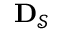Convert formula to latex. <formula><loc_0><loc_0><loc_500><loc_500>{ D } _ { \mathcal { S } }</formula> 